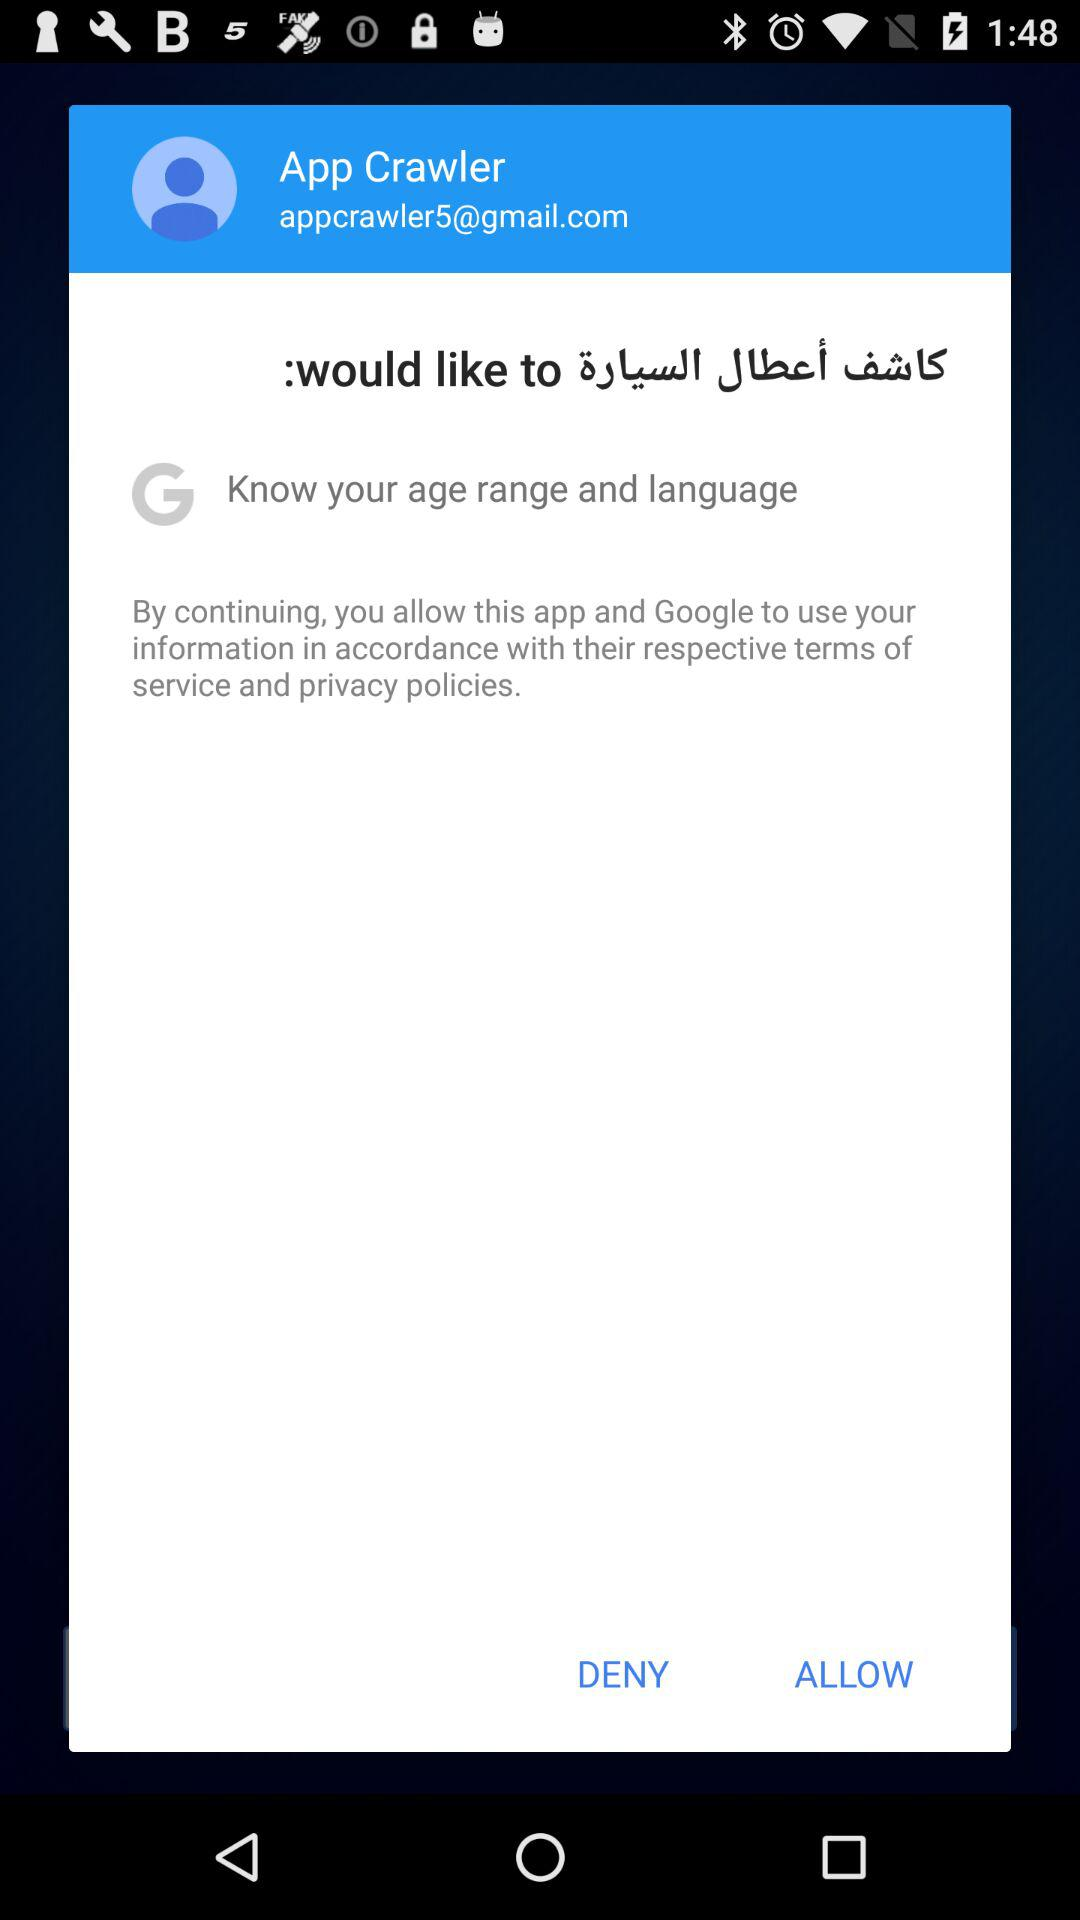What is the email address? The email address is appcrawler5@gmail.com. 